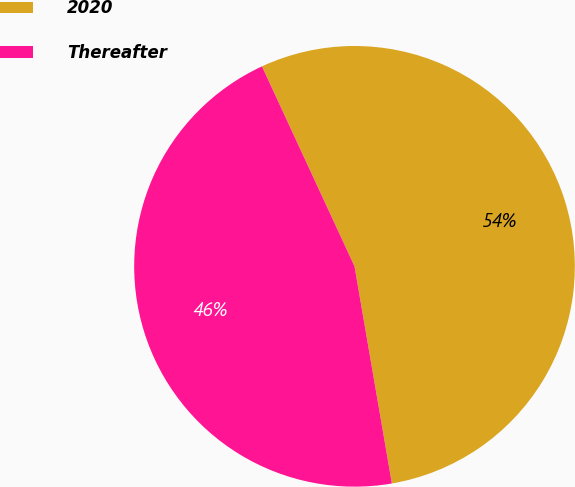Convert chart. <chart><loc_0><loc_0><loc_500><loc_500><pie_chart><fcel>2020<fcel>Thereafter<nl><fcel>54.19%<fcel>45.81%<nl></chart> 